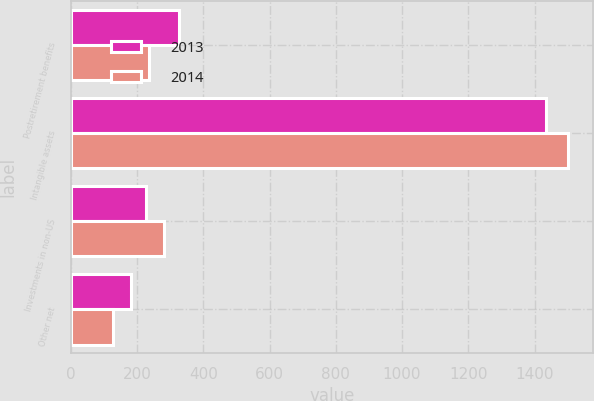Convert chart. <chart><loc_0><loc_0><loc_500><loc_500><stacked_bar_chart><ecel><fcel>Postretirement benefits<fcel>Intangible assets<fcel>Investments in non-US<fcel>Other net<nl><fcel>2013<fcel>327<fcel>1435<fcel>227<fcel>183<nl><fcel>2014<fcel>236<fcel>1502<fcel>282<fcel>128<nl></chart> 